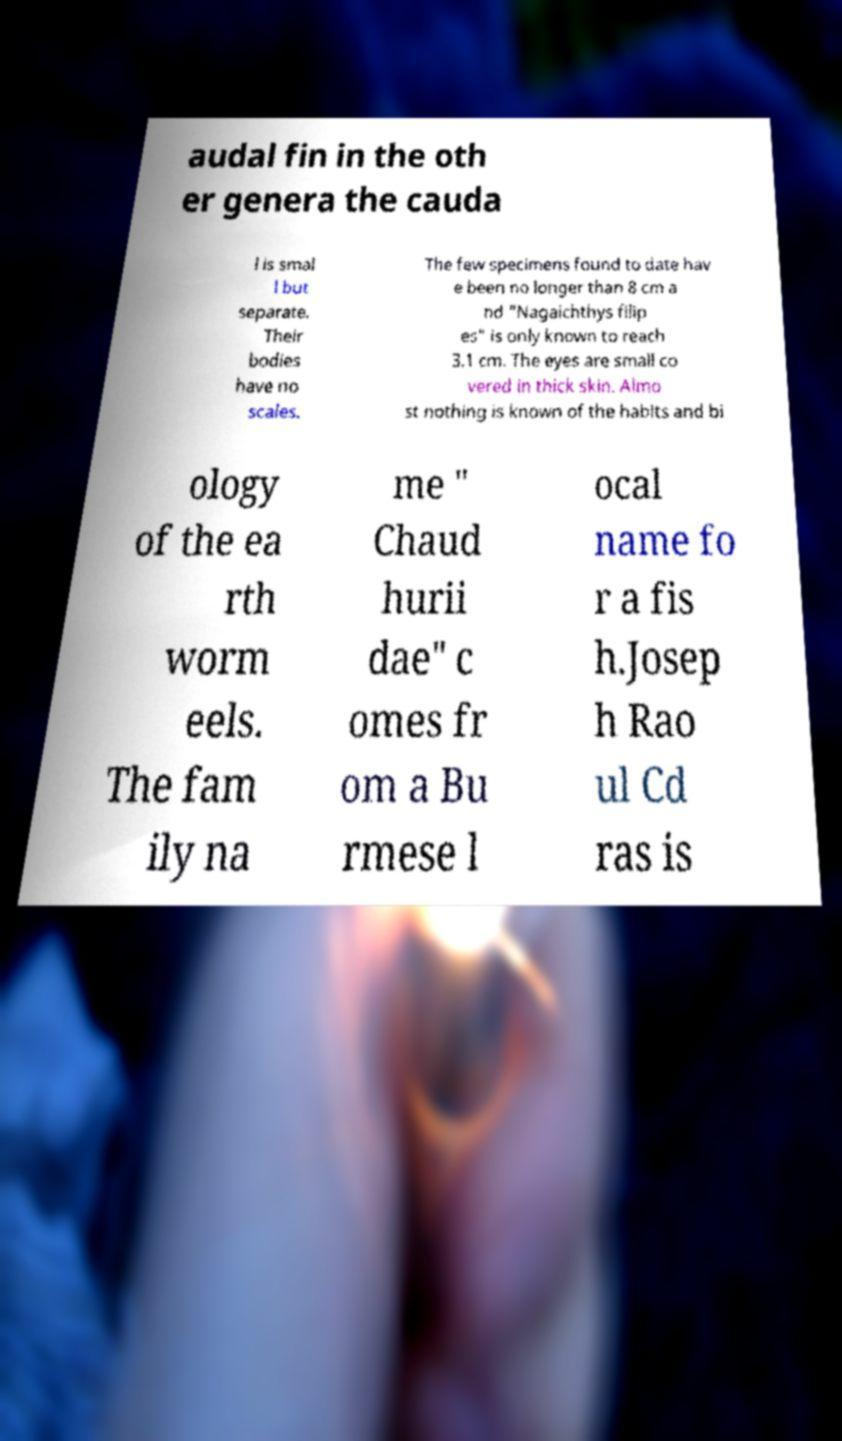For documentation purposes, I need the text within this image transcribed. Could you provide that? audal fin in the oth er genera the cauda l is smal l but separate. Their bodies have no scales. The few specimens found to date hav e been no longer than 8 cm a nd "Nagaichthys filip es" is only known to reach 3.1 cm. The eyes are small co vered in thick skin. Almo st nothing is known of the habits and bi ology of the ea rth worm eels. The fam ily na me " Chaud hurii dae" c omes fr om a Bu rmese l ocal name fo r a fis h.Josep h Rao ul Cd ras is 